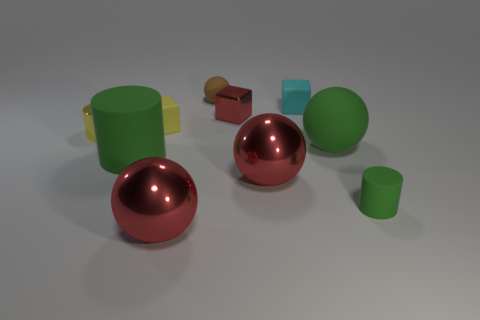Subtract all big green matte spheres. How many spheres are left? 3 Subtract 1 spheres. How many spheres are left? 3 Subtract all green balls. How many balls are left? 3 Subtract all purple balls. Subtract all red cylinders. How many balls are left? 4 Subtract all cylinders. How many objects are left? 7 Add 2 tiny rubber cubes. How many tiny rubber cubes exist? 4 Subtract 0 yellow spheres. How many objects are left? 10 Subtract all purple metallic balls. Subtract all yellow objects. How many objects are left? 8 Add 6 tiny cubes. How many tiny cubes are left? 9 